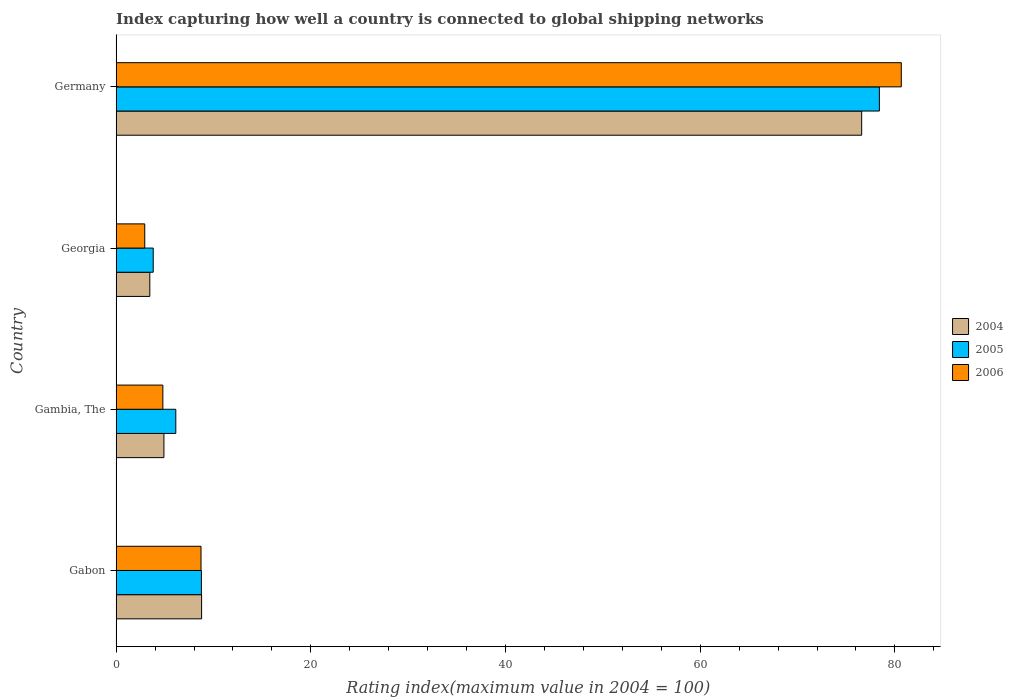How many different coloured bars are there?
Provide a short and direct response. 3. How many bars are there on the 3rd tick from the bottom?
Give a very brief answer. 3. What is the rating index in 2006 in Georgia?
Offer a terse response. 2.94. Across all countries, what is the maximum rating index in 2004?
Offer a very short reply. 76.59. Across all countries, what is the minimum rating index in 2006?
Your response must be concise. 2.94. In which country was the rating index in 2004 minimum?
Provide a succinct answer. Georgia. What is the total rating index in 2005 in the graph?
Keep it short and to the point. 97.11. What is the difference between the rating index in 2004 in Gabon and that in Georgia?
Ensure brevity in your answer.  5.32. What is the difference between the rating index in 2005 in Germany and the rating index in 2004 in Gabon?
Ensure brevity in your answer.  69.63. What is the average rating index in 2006 per country?
Keep it short and to the point. 24.28. What is the difference between the rating index in 2006 and rating index in 2005 in Georgia?
Provide a short and direct response. -0.87. In how many countries, is the rating index in 2005 greater than 8 ?
Provide a short and direct response. 2. What is the ratio of the rating index in 2004 in Gambia, The to that in Georgia?
Your answer should be very brief. 1.42. What is the difference between the highest and the second highest rating index in 2006?
Ensure brevity in your answer.  71.94. What is the difference between the highest and the lowest rating index in 2006?
Make the answer very short. 77.72. What does the 1st bar from the bottom in Gambia, The represents?
Provide a short and direct response. 2004. How many bars are there?
Your answer should be compact. 12. Are all the bars in the graph horizontal?
Your answer should be very brief. Yes. Are the values on the major ticks of X-axis written in scientific E-notation?
Make the answer very short. No. Does the graph contain grids?
Provide a succinct answer. No. Where does the legend appear in the graph?
Provide a short and direct response. Center right. How many legend labels are there?
Provide a short and direct response. 3. How are the legend labels stacked?
Your answer should be compact. Vertical. What is the title of the graph?
Provide a succinct answer. Index capturing how well a country is connected to global shipping networks. Does "1963" appear as one of the legend labels in the graph?
Your answer should be very brief. No. What is the label or title of the X-axis?
Keep it short and to the point. Rating index(maximum value in 2004 = 100). What is the Rating index(maximum value in 2004 = 100) in 2004 in Gabon?
Keep it short and to the point. 8.78. What is the Rating index(maximum value in 2004 = 100) in 2005 in Gabon?
Keep it short and to the point. 8.76. What is the Rating index(maximum value in 2004 = 100) in 2006 in Gabon?
Your answer should be compact. 8.72. What is the Rating index(maximum value in 2004 = 100) in 2004 in Gambia, The?
Your answer should be compact. 4.91. What is the Rating index(maximum value in 2004 = 100) of 2005 in Gambia, The?
Make the answer very short. 6.13. What is the Rating index(maximum value in 2004 = 100) in 2004 in Georgia?
Give a very brief answer. 3.46. What is the Rating index(maximum value in 2004 = 100) in 2005 in Georgia?
Give a very brief answer. 3.81. What is the Rating index(maximum value in 2004 = 100) of 2006 in Georgia?
Give a very brief answer. 2.94. What is the Rating index(maximum value in 2004 = 100) in 2004 in Germany?
Provide a short and direct response. 76.59. What is the Rating index(maximum value in 2004 = 100) in 2005 in Germany?
Make the answer very short. 78.41. What is the Rating index(maximum value in 2004 = 100) of 2006 in Germany?
Provide a succinct answer. 80.66. Across all countries, what is the maximum Rating index(maximum value in 2004 = 100) in 2004?
Your answer should be very brief. 76.59. Across all countries, what is the maximum Rating index(maximum value in 2004 = 100) of 2005?
Keep it short and to the point. 78.41. Across all countries, what is the maximum Rating index(maximum value in 2004 = 100) in 2006?
Your response must be concise. 80.66. Across all countries, what is the minimum Rating index(maximum value in 2004 = 100) of 2004?
Your response must be concise. 3.46. Across all countries, what is the minimum Rating index(maximum value in 2004 = 100) in 2005?
Keep it short and to the point. 3.81. Across all countries, what is the minimum Rating index(maximum value in 2004 = 100) of 2006?
Provide a succinct answer. 2.94. What is the total Rating index(maximum value in 2004 = 100) of 2004 in the graph?
Give a very brief answer. 93.74. What is the total Rating index(maximum value in 2004 = 100) of 2005 in the graph?
Ensure brevity in your answer.  97.11. What is the total Rating index(maximum value in 2004 = 100) of 2006 in the graph?
Provide a short and direct response. 97.12. What is the difference between the Rating index(maximum value in 2004 = 100) of 2004 in Gabon and that in Gambia, The?
Your answer should be very brief. 3.87. What is the difference between the Rating index(maximum value in 2004 = 100) in 2005 in Gabon and that in Gambia, The?
Offer a very short reply. 2.63. What is the difference between the Rating index(maximum value in 2004 = 100) in 2006 in Gabon and that in Gambia, The?
Provide a succinct answer. 3.92. What is the difference between the Rating index(maximum value in 2004 = 100) of 2004 in Gabon and that in Georgia?
Make the answer very short. 5.32. What is the difference between the Rating index(maximum value in 2004 = 100) of 2005 in Gabon and that in Georgia?
Offer a terse response. 4.95. What is the difference between the Rating index(maximum value in 2004 = 100) of 2006 in Gabon and that in Georgia?
Offer a very short reply. 5.78. What is the difference between the Rating index(maximum value in 2004 = 100) in 2004 in Gabon and that in Germany?
Your answer should be very brief. -67.81. What is the difference between the Rating index(maximum value in 2004 = 100) in 2005 in Gabon and that in Germany?
Ensure brevity in your answer.  -69.65. What is the difference between the Rating index(maximum value in 2004 = 100) of 2006 in Gabon and that in Germany?
Your answer should be compact. -71.94. What is the difference between the Rating index(maximum value in 2004 = 100) in 2004 in Gambia, The and that in Georgia?
Your answer should be very brief. 1.45. What is the difference between the Rating index(maximum value in 2004 = 100) in 2005 in Gambia, The and that in Georgia?
Your response must be concise. 2.32. What is the difference between the Rating index(maximum value in 2004 = 100) in 2006 in Gambia, The and that in Georgia?
Make the answer very short. 1.86. What is the difference between the Rating index(maximum value in 2004 = 100) in 2004 in Gambia, The and that in Germany?
Your response must be concise. -71.68. What is the difference between the Rating index(maximum value in 2004 = 100) in 2005 in Gambia, The and that in Germany?
Your answer should be compact. -72.28. What is the difference between the Rating index(maximum value in 2004 = 100) of 2006 in Gambia, The and that in Germany?
Your response must be concise. -75.86. What is the difference between the Rating index(maximum value in 2004 = 100) in 2004 in Georgia and that in Germany?
Provide a succinct answer. -73.13. What is the difference between the Rating index(maximum value in 2004 = 100) of 2005 in Georgia and that in Germany?
Offer a very short reply. -74.6. What is the difference between the Rating index(maximum value in 2004 = 100) of 2006 in Georgia and that in Germany?
Make the answer very short. -77.72. What is the difference between the Rating index(maximum value in 2004 = 100) in 2004 in Gabon and the Rating index(maximum value in 2004 = 100) in 2005 in Gambia, The?
Provide a short and direct response. 2.65. What is the difference between the Rating index(maximum value in 2004 = 100) in 2004 in Gabon and the Rating index(maximum value in 2004 = 100) in 2006 in Gambia, The?
Keep it short and to the point. 3.98. What is the difference between the Rating index(maximum value in 2004 = 100) in 2005 in Gabon and the Rating index(maximum value in 2004 = 100) in 2006 in Gambia, The?
Ensure brevity in your answer.  3.96. What is the difference between the Rating index(maximum value in 2004 = 100) of 2004 in Gabon and the Rating index(maximum value in 2004 = 100) of 2005 in Georgia?
Provide a succinct answer. 4.97. What is the difference between the Rating index(maximum value in 2004 = 100) of 2004 in Gabon and the Rating index(maximum value in 2004 = 100) of 2006 in Georgia?
Provide a succinct answer. 5.84. What is the difference between the Rating index(maximum value in 2004 = 100) in 2005 in Gabon and the Rating index(maximum value in 2004 = 100) in 2006 in Georgia?
Keep it short and to the point. 5.82. What is the difference between the Rating index(maximum value in 2004 = 100) in 2004 in Gabon and the Rating index(maximum value in 2004 = 100) in 2005 in Germany?
Offer a terse response. -69.63. What is the difference between the Rating index(maximum value in 2004 = 100) in 2004 in Gabon and the Rating index(maximum value in 2004 = 100) in 2006 in Germany?
Your answer should be compact. -71.88. What is the difference between the Rating index(maximum value in 2004 = 100) of 2005 in Gabon and the Rating index(maximum value in 2004 = 100) of 2006 in Germany?
Ensure brevity in your answer.  -71.9. What is the difference between the Rating index(maximum value in 2004 = 100) of 2004 in Gambia, The and the Rating index(maximum value in 2004 = 100) of 2006 in Georgia?
Offer a terse response. 1.97. What is the difference between the Rating index(maximum value in 2004 = 100) in 2005 in Gambia, The and the Rating index(maximum value in 2004 = 100) in 2006 in Georgia?
Your answer should be compact. 3.19. What is the difference between the Rating index(maximum value in 2004 = 100) of 2004 in Gambia, The and the Rating index(maximum value in 2004 = 100) of 2005 in Germany?
Offer a terse response. -73.5. What is the difference between the Rating index(maximum value in 2004 = 100) of 2004 in Gambia, The and the Rating index(maximum value in 2004 = 100) of 2006 in Germany?
Your answer should be very brief. -75.75. What is the difference between the Rating index(maximum value in 2004 = 100) of 2005 in Gambia, The and the Rating index(maximum value in 2004 = 100) of 2006 in Germany?
Ensure brevity in your answer.  -74.53. What is the difference between the Rating index(maximum value in 2004 = 100) of 2004 in Georgia and the Rating index(maximum value in 2004 = 100) of 2005 in Germany?
Offer a very short reply. -74.95. What is the difference between the Rating index(maximum value in 2004 = 100) in 2004 in Georgia and the Rating index(maximum value in 2004 = 100) in 2006 in Germany?
Provide a succinct answer. -77.2. What is the difference between the Rating index(maximum value in 2004 = 100) in 2005 in Georgia and the Rating index(maximum value in 2004 = 100) in 2006 in Germany?
Keep it short and to the point. -76.85. What is the average Rating index(maximum value in 2004 = 100) in 2004 per country?
Provide a succinct answer. 23.43. What is the average Rating index(maximum value in 2004 = 100) in 2005 per country?
Offer a very short reply. 24.28. What is the average Rating index(maximum value in 2004 = 100) in 2006 per country?
Ensure brevity in your answer.  24.28. What is the difference between the Rating index(maximum value in 2004 = 100) of 2004 and Rating index(maximum value in 2004 = 100) of 2005 in Gabon?
Your answer should be compact. 0.02. What is the difference between the Rating index(maximum value in 2004 = 100) of 2004 and Rating index(maximum value in 2004 = 100) of 2005 in Gambia, The?
Keep it short and to the point. -1.22. What is the difference between the Rating index(maximum value in 2004 = 100) in 2004 and Rating index(maximum value in 2004 = 100) in 2006 in Gambia, The?
Your response must be concise. 0.11. What is the difference between the Rating index(maximum value in 2004 = 100) of 2005 and Rating index(maximum value in 2004 = 100) of 2006 in Gambia, The?
Ensure brevity in your answer.  1.33. What is the difference between the Rating index(maximum value in 2004 = 100) in 2004 and Rating index(maximum value in 2004 = 100) in 2005 in Georgia?
Keep it short and to the point. -0.35. What is the difference between the Rating index(maximum value in 2004 = 100) in 2004 and Rating index(maximum value in 2004 = 100) in 2006 in Georgia?
Give a very brief answer. 0.52. What is the difference between the Rating index(maximum value in 2004 = 100) in 2005 and Rating index(maximum value in 2004 = 100) in 2006 in Georgia?
Your response must be concise. 0.87. What is the difference between the Rating index(maximum value in 2004 = 100) in 2004 and Rating index(maximum value in 2004 = 100) in 2005 in Germany?
Ensure brevity in your answer.  -1.82. What is the difference between the Rating index(maximum value in 2004 = 100) of 2004 and Rating index(maximum value in 2004 = 100) of 2006 in Germany?
Offer a terse response. -4.07. What is the difference between the Rating index(maximum value in 2004 = 100) in 2005 and Rating index(maximum value in 2004 = 100) in 2006 in Germany?
Your answer should be very brief. -2.25. What is the ratio of the Rating index(maximum value in 2004 = 100) of 2004 in Gabon to that in Gambia, The?
Offer a very short reply. 1.79. What is the ratio of the Rating index(maximum value in 2004 = 100) in 2005 in Gabon to that in Gambia, The?
Ensure brevity in your answer.  1.43. What is the ratio of the Rating index(maximum value in 2004 = 100) in 2006 in Gabon to that in Gambia, The?
Provide a succinct answer. 1.82. What is the ratio of the Rating index(maximum value in 2004 = 100) in 2004 in Gabon to that in Georgia?
Offer a terse response. 2.54. What is the ratio of the Rating index(maximum value in 2004 = 100) of 2005 in Gabon to that in Georgia?
Make the answer very short. 2.3. What is the ratio of the Rating index(maximum value in 2004 = 100) of 2006 in Gabon to that in Georgia?
Provide a short and direct response. 2.97. What is the ratio of the Rating index(maximum value in 2004 = 100) in 2004 in Gabon to that in Germany?
Provide a short and direct response. 0.11. What is the ratio of the Rating index(maximum value in 2004 = 100) in 2005 in Gabon to that in Germany?
Give a very brief answer. 0.11. What is the ratio of the Rating index(maximum value in 2004 = 100) in 2006 in Gabon to that in Germany?
Your answer should be compact. 0.11. What is the ratio of the Rating index(maximum value in 2004 = 100) of 2004 in Gambia, The to that in Georgia?
Make the answer very short. 1.42. What is the ratio of the Rating index(maximum value in 2004 = 100) of 2005 in Gambia, The to that in Georgia?
Your response must be concise. 1.61. What is the ratio of the Rating index(maximum value in 2004 = 100) in 2006 in Gambia, The to that in Georgia?
Your answer should be very brief. 1.63. What is the ratio of the Rating index(maximum value in 2004 = 100) of 2004 in Gambia, The to that in Germany?
Your response must be concise. 0.06. What is the ratio of the Rating index(maximum value in 2004 = 100) of 2005 in Gambia, The to that in Germany?
Your response must be concise. 0.08. What is the ratio of the Rating index(maximum value in 2004 = 100) of 2006 in Gambia, The to that in Germany?
Make the answer very short. 0.06. What is the ratio of the Rating index(maximum value in 2004 = 100) of 2004 in Georgia to that in Germany?
Ensure brevity in your answer.  0.05. What is the ratio of the Rating index(maximum value in 2004 = 100) in 2005 in Georgia to that in Germany?
Offer a very short reply. 0.05. What is the ratio of the Rating index(maximum value in 2004 = 100) in 2006 in Georgia to that in Germany?
Your response must be concise. 0.04. What is the difference between the highest and the second highest Rating index(maximum value in 2004 = 100) of 2004?
Your answer should be very brief. 67.81. What is the difference between the highest and the second highest Rating index(maximum value in 2004 = 100) of 2005?
Provide a short and direct response. 69.65. What is the difference between the highest and the second highest Rating index(maximum value in 2004 = 100) of 2006?
Keep it short and to the point. 71.94. What is the difference between the highest and the lowest Rating index(maximum value in 2004 = 100) in 2004?
Make the answer very short. 73.13. What is the difference between the highest and the lowest Rating index(maximum value in 2004 = 100) of 2005?
Give a very brief answer. 74.6. What is the difference between the highest and the lowest Rating index(maximum value in 2004 = 100) in 2006?
Make the answer very short. 77.72. 